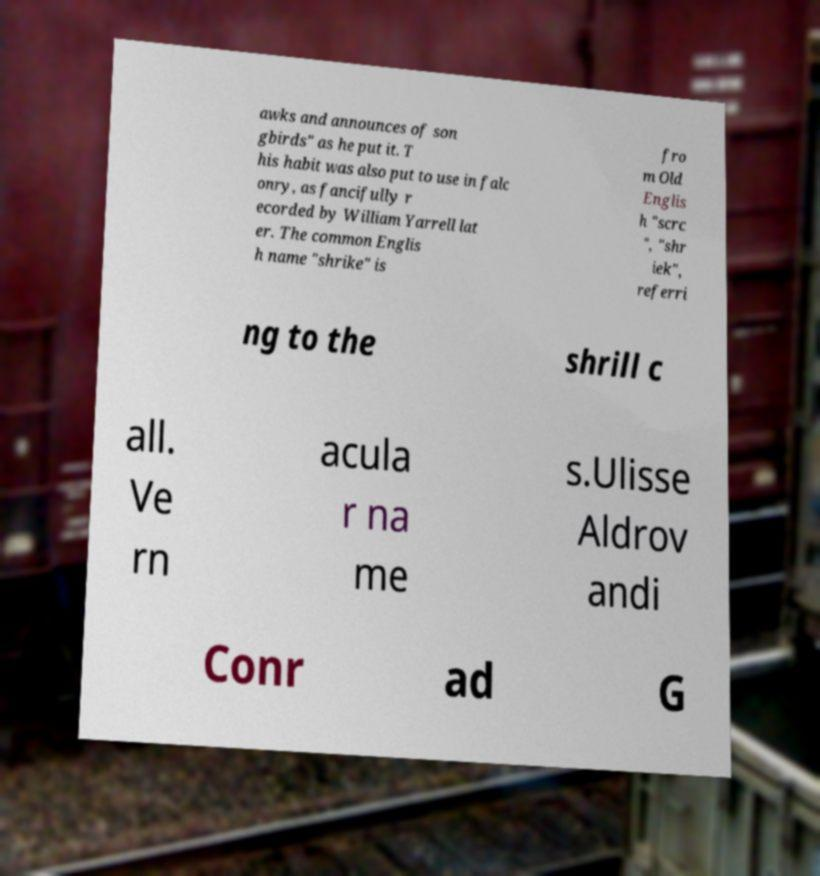Please identify and transcribe the text found in this image. awks and announces of son gbirds" as he put it. T his habit was also put to use in falc onry, as fancifully r ecorded by William Yarrell lat er. The common Englis h name "shrike" is fro m Old Englis h "scrc ", "shr iek", referri ng to the shrill c all. Ve rn acula r na me s.Ulisse Aldrov andi Conr ad G 